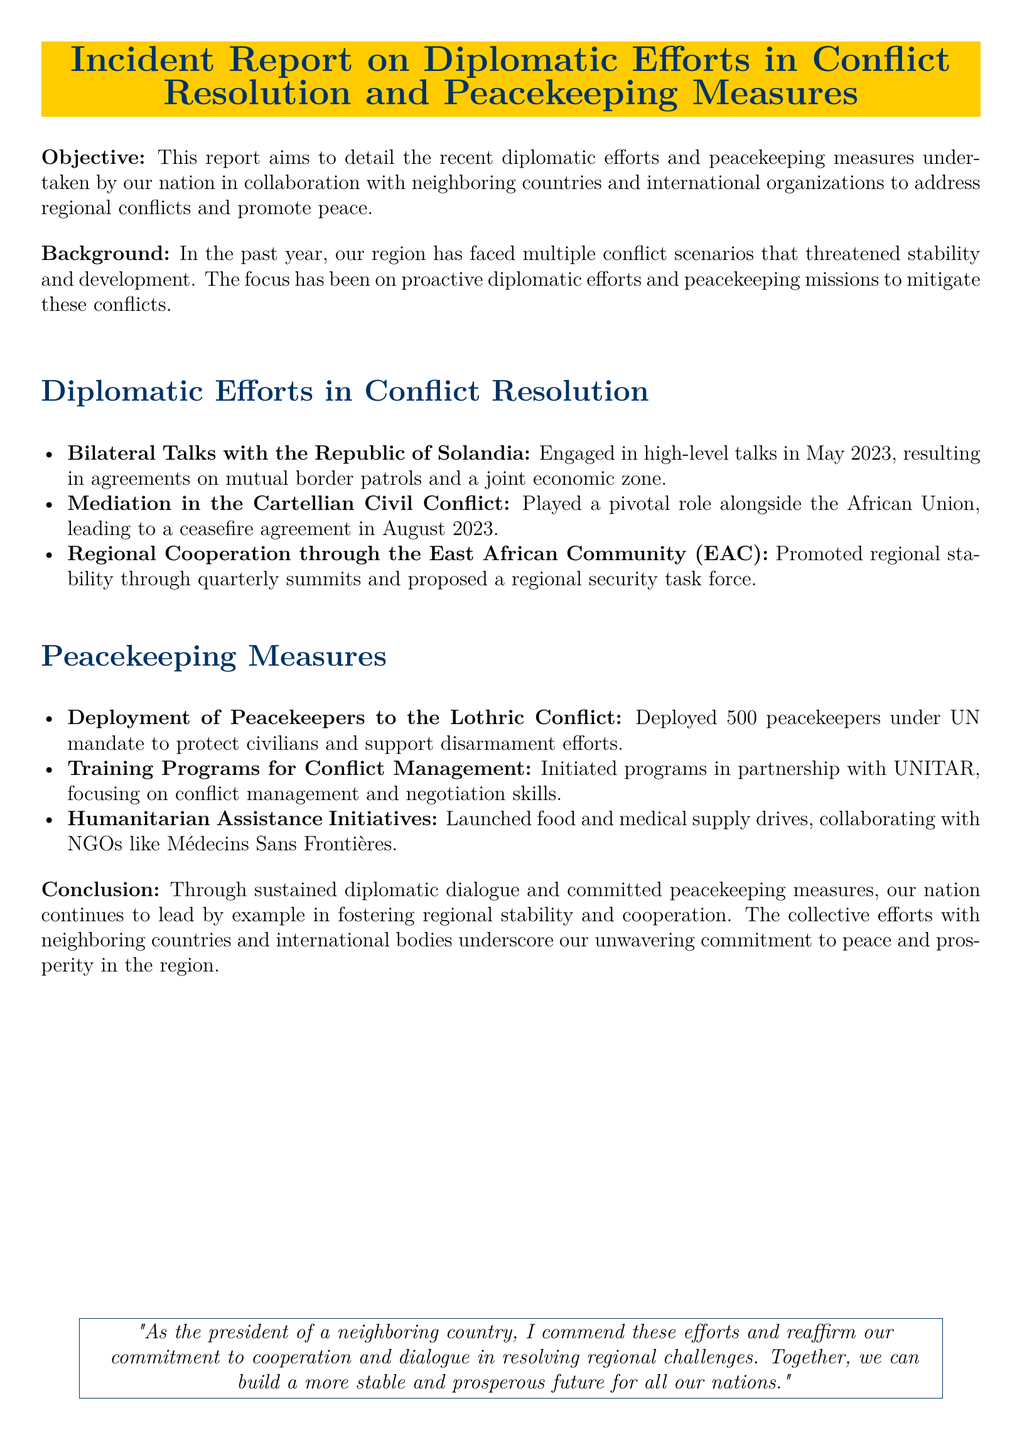What is the objective of the report? The objective is to detail the recent diplomatic efforts and peacekeeping measures undertaken by the nation in collaboration with neighboring countries and international organizations.
Answer: detail the recent diplomatic efforts and peacekeeping measures When did the bilateral talks with the Republic of Solandia take place? The document states that the talks occurred in May 2023.
Answer: May 2023 How many peacekeepers were deployed to the Lothric Conflict? The report specifies the deployment of 500 peacekeepers.
Answer: 500 What major role did our nation play in the Cartellian Civil Conflict? The nation played a pivotal role alongside the African Union, leading to a ceasefire agreement.
Answer: pivotal role alongside the African Union What initiative was launched in collaboration with Médecins Sans Frontières? The document mentions a food and medical supply drive as part of humanitarian assistance initiatives.
Answer: food and medical supply drives How often are the quarterly summits held through the East African Community? The summits are held quarterly as indicated in the document.
Answer: quarterly What type of training programs were initiated in partnership with UNITAR? The training programs are focused on conflict management and negotiation skills.
Answer: conflict management and negotiation skills What is the overall conclusion outlined in the report? The conclusion highlights the commitment to fostering regional stability and cooperation through diplomatic dialogue and peacekeeping measures.
Answer: commitment to fostering regional stability and cooperation 